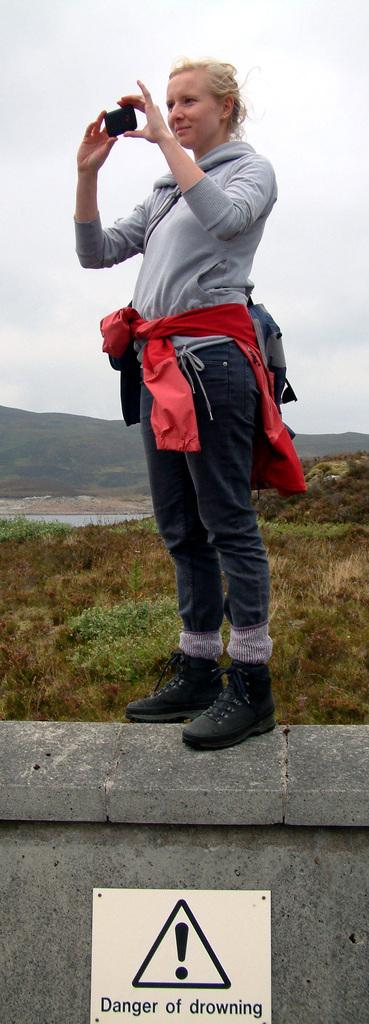What is the person in the image doing? The person is standing on a wall in the image. What can be seen on the board in the image? There is a board with text in the image. What type of vegetation is present beside the board? There are plants beside the board. What is visible in the background of the image? Water and a clear sky are visible in the image. What type of heart can be seen floating in the water in the image? There is no heart visible in the image; it only features a person standing on a wall, a board with text, plants, water, and a clear sky. 